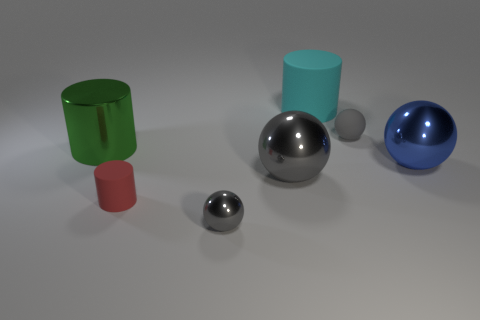Subtract all gray balls. How many were subtracted if there are1gray balls left? 2 Subtract all big cylinders. How many cylinders are left? 1 Subtract all blue spheres. How many spheres are left? 3 Add 1 large blue balls. How many objects exist? 8 Subtract all cylinders. How many objects are left? 4 Subtract all cyan spheres. How many red cylinders are left? 1 Subtract all large blue things. Subtract all green things. How many objects are left? 5 Add 7 cyan cylinders. How many cyan cylinders are left? 8 Add 1 big gray shiny spheres. How many big gray shiny spheres exist? 2 Subtract 0 blue cylinders. How many objects are left? 7 